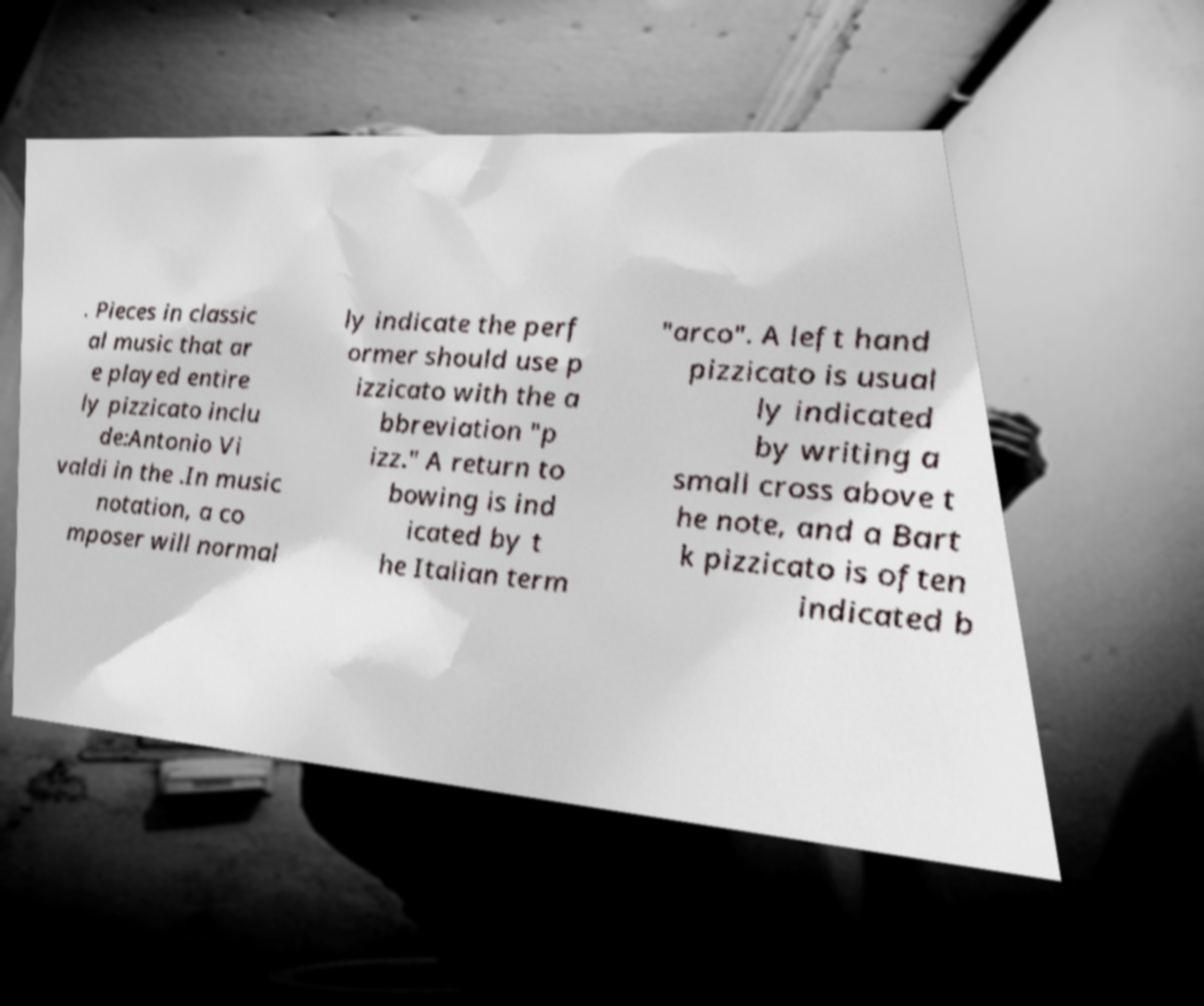What messages or text are displayed in this image? I need them in a readable, typed format. . Pieces in classic al music that ar e played entire ly pizzicato inclu de:Antonio Vi valdi in the .In music notation, a co mposer will normal ly indicate the perf ormer should use p izzicato with the a bbreviation "p izz." A return to bowing is ind icated by t he Italian term "arco". A left hand pizzicato is usual ly indicated by writing a small cross above t he note, and a Bart k pizzicato is often indicated b 